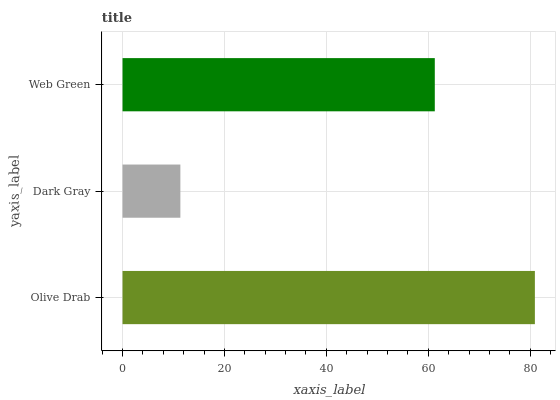Is Dark Gray the minimum?
Answer yes or no. Yes. Is Olive Drab the maximum?
Answer yes or no. Yes. Is Web Green the minimum?
Answer yes or no. No. Is Web Green the maximum?
Answer yes or no. No. Is Web Green greater than Dark Gray?
Answer yes or no. Yes. Is Dark Gray less than Web Green?
Answer yes or no. Yes. Is Dark Gray greater than Web Green?
Answer yes or no. No. Is Web Green less than Dark Gray?
Answer yes or no. No. Is Web Green the high median?
Answer yes or no. Yes. Is Web Green the low median?
Answer yes or no. Yes. Is Olive Drab the high median?
Answer yes or no. No. Is Dark Gray the low median?
Answer yes or no. No. 